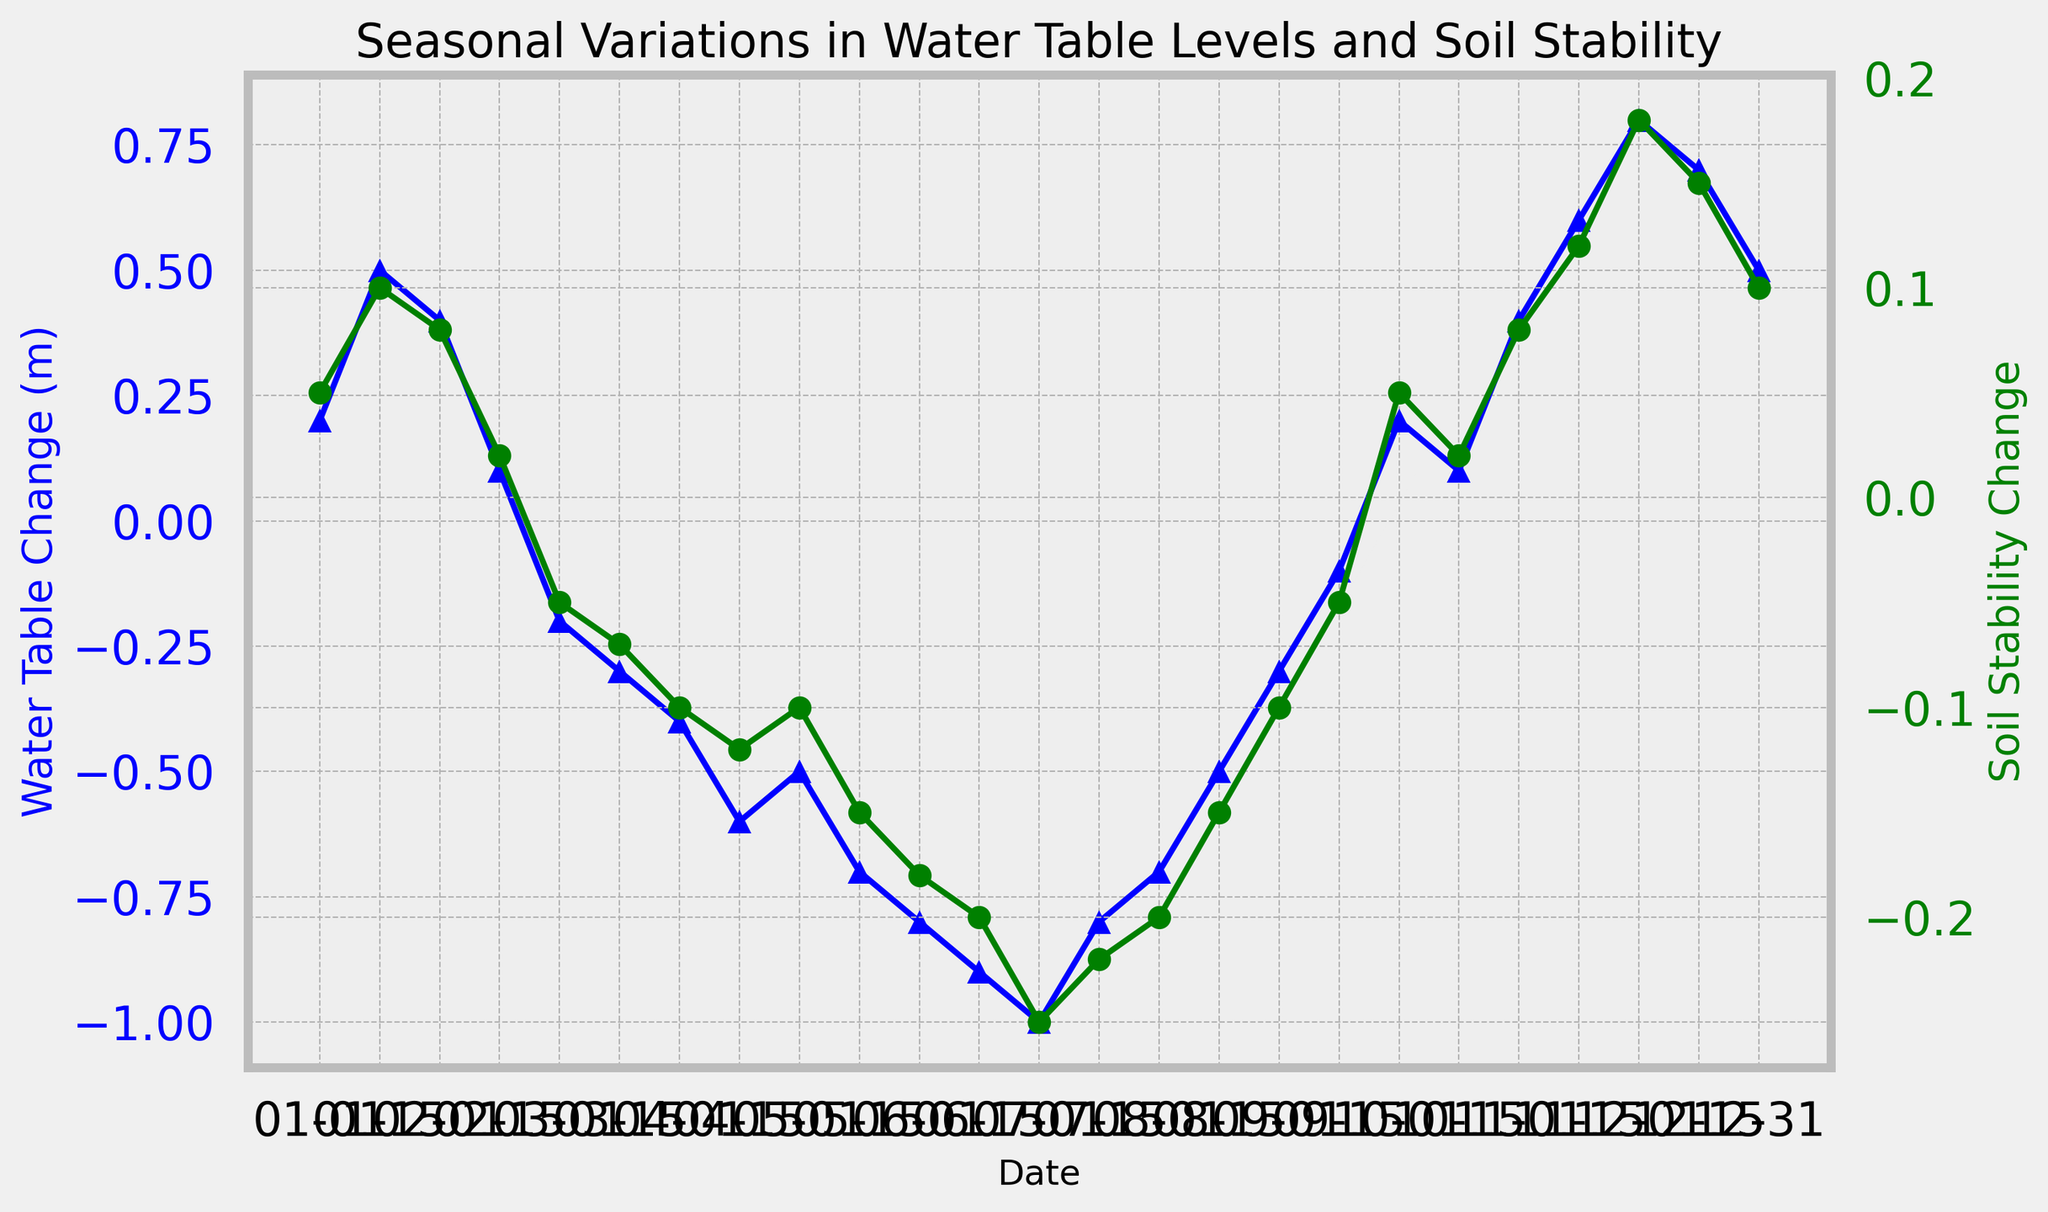What is the peak negative value of the water table change and when does it occur? The lowest point on the blue line (water table change) can be identified visually as -1.0 m, which appears on July 1.
Answer: -1.0 m on July 1 What is the average soil stability change from June 1 to July 15? From June 1 to July 15, the data points for soil stability change are -0.18, -0.2, -0.25, and -0.22. Summing these gives -0.85. Divide this by 4 to get the average: -0.85 / 4 = -0.2125.
Answer: -0.2125 During which months do we observe a positive water table change? The blue line crosses above 0 on the x-axis from January to February and from October to December.
Answer: January-February, October-December Between March 1 and April 15, how does the water table change compare to the soil stability change? Both metrics show a decline, with the water table change falling from -0.2 m to -0.6 m and soil stability change falling from -0.05 to -0.12 during this period.
Answer: Both decreased Which month shows the greatest improvement in soil stability change and what is the value? The green line reaches its highest positive value in December 1, at which point the change in soil stability is 0.18.
Answer: December 1, 0.18 What is the range of water table changes observed in the year? The highest is 0.8 m in December, and the lowest is -1.0 m in July. The range is the difference between these two values: 0.8 - (-1.0) = 1.8.
Answer: 1.8 When soil stability is the lowest, what is the corresponding water table change? The lowest soil stability change is -0.25 on July 1, which coincides with the water table change of -1.0 m.
Answer: -1.0 m How does the water table change in the first half of the year (January to June) compare to the second half (July to December)? The water table change is positive in January-February but turns negative by March, reaching its lowest in July (-1.0). After July, it gradually recovers to reach positive values again in October-December. Generally, the water table is lower in the first half of the year.
Answer: Lower in the first half When the water table change is -0.6 m, what is the soil stability change, and on which date does it occur? The water table change of -0.6 m corresponds to a soil stability change of -0.12 on April 15.
Answer: -0.12 on April 15 